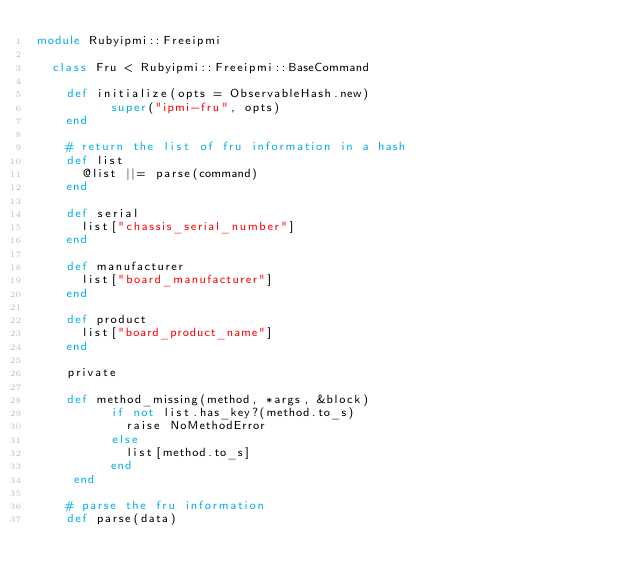<code> <loc_0><loc_0><loc_500><loc_500><_Ruby_>module Rubyipmi::Freeipmi

  class Fru < Rubyipmi::Freeipmi::BaseCommand

    def initialize(opts = ObservableHash.new)
          super("ipmi-fru", opts)
    end

    # return the list of fru information in a hash
    def list
      @list ||= parse(command)
    end

    def serial
      list["chassis_serial_number"]
    end

    def manufacturer
      list["board_manufacturer"]
    end

    def product
      list["board_product_name"]
    end

    private

    def method_missing(method, *args, &block)
          if not list.has_key?(method.to_s)
            raise NoMethodError
          else
            list[method.to_s]
          end
     end

    # parse the fru information
    def parse(data)</code> 